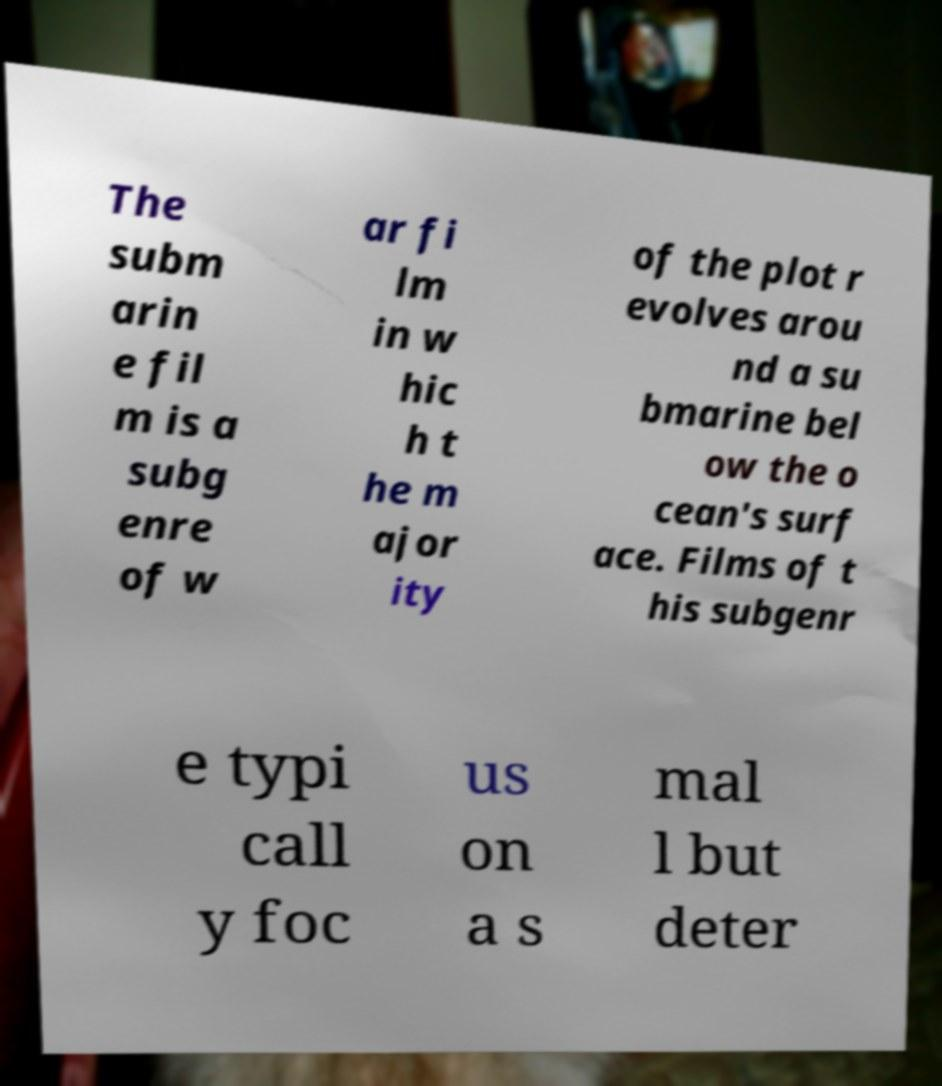Can you accurately transcribe the text from the provided image for me? The subm arin e fil m is a subg enre of w ar fi lm in w hic h t he m ajor ity of the plot r evolves arou nd a su bmarine bel ow the o cean's surf ace. Films of t his subgenr e typi call y foc us on a s mal l but deter 